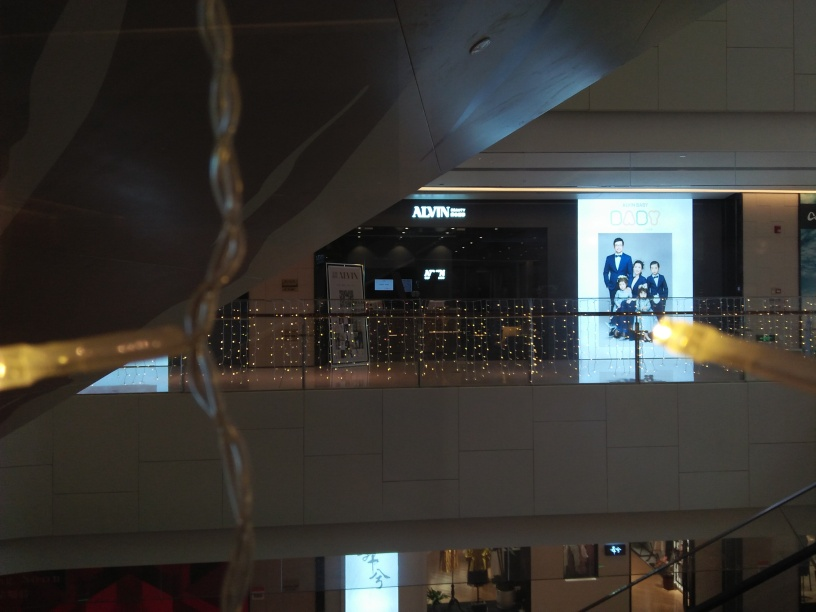How does the lighting affect the mood of this environment? The warm glow from the decorative lights adds a festive and welcoming atmosphere to the environment. It casts a soft illumination that enhances the aesthetic appeal of the space, making it feel cozy despite the commercial setting. the bright spotlights and reflections convey energy and vibrancy. 